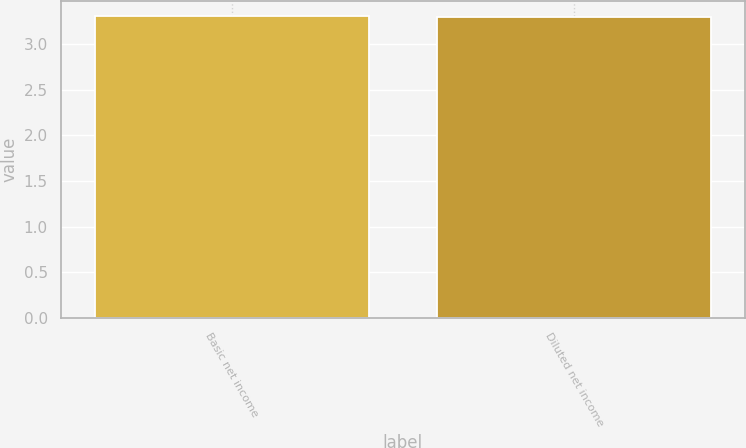<chart> <loc_0><loc_0><loc_500><loc_500><bar_chart><fcel>Basic net income<fcel>Diluted net income<nl><fcel>3.31<fcel>3.3<nl></chart> 